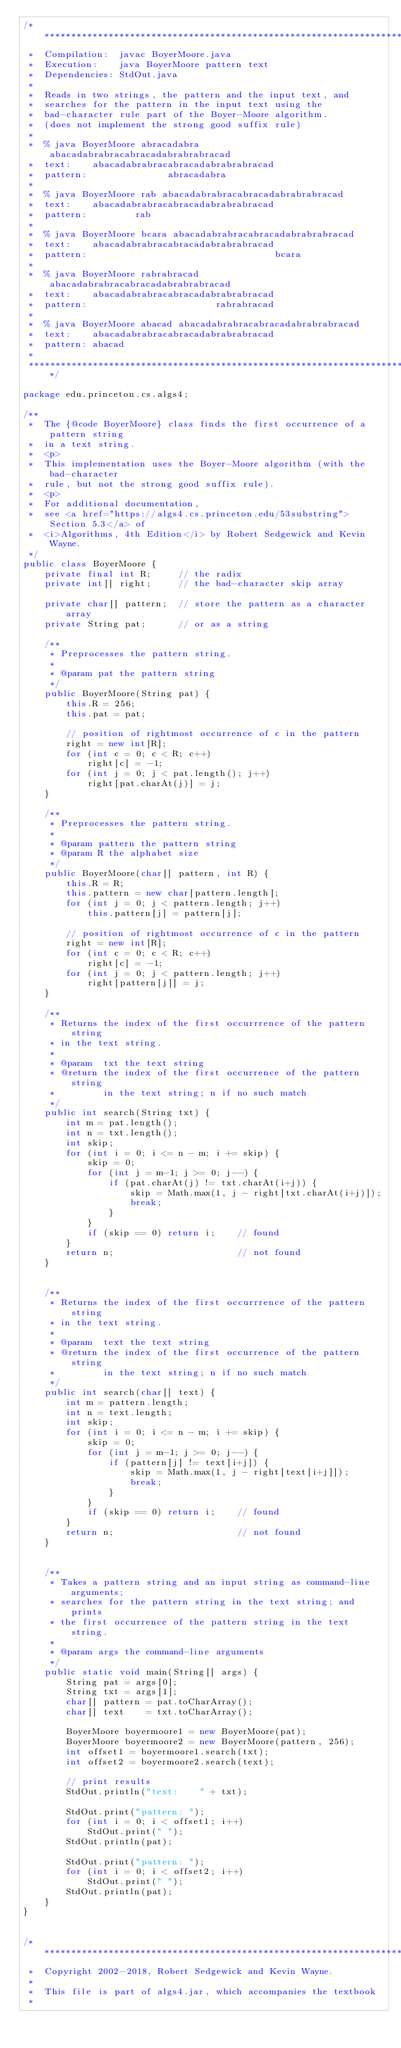<code> <loc_0><loc_0><loc_500><loc_500><_Java_>/******************************************************************************
 *  Compilation:  javac BoyerMoore.java
 *  Execution:    java BoyerMoore pattern text
 *  Dependencies: StdOut.java
 *
 *  Reads in two strings, the pattern and the input text, and
 *  searches for the pattern in the input text using the
 *  bad-character rule part of the Boyer-Moore algorithm.
 *  (does not implement the strong good suffix rule)
 *
 *  % java BoyerMoore abracadabra abacadabrabracabracadabrabrabracad
 *  text:    abacadabrabracabracadabrabrabracad 
 *  pattern:               abracadabra
 *
 *  % java BoyerMoore rab abacadabrabracabracadabrabrabracad
 *  text:    abacadabrabracabracadabrabrabracad 
 *  pattern:         rab
 *
 *  % java BoyerMoore bcara abacadabrabracabracadabrabrabracad
 *  text:    abacadabrabracabracadabrabrabracad 
 *  pattern:                                   bcara
 *
 *  % java BoyerMoore rabrabracad abacadabrabracabracadabrabrabracad
 *  text:    abacadabrabracabracadabrabrabracad
 *  pattern:                        rabrabracad
 *
 *  % java BoyerMoore abacad abacadabrabracabracadabrabrabracad
 *  text:    abacadabrabracabracadabrabrabracad
 *  pattern: abacad
 *
 ******************************************************************************/

package edu.princeton.cs.algs4;

/**
 *  The {@code BoyerMoore} class finds the first occurrence of a pattern string
 *  in a text string.
 *  <p>
 *  This implementation uses the Boyer-Moore algorithm (with the bad-character
 *  rule, but not the strong good suffix rule).
 *  <p>
 *  For additional documentation,
 *  see <a href="https://algs4.cs.princeton.edu/53substring">Section 5.3</a> of
 *  <i>Algorithms, 4th Edition</i> by Robert Sedgewick and Kevin Wayne.
 */
public class BoyerMoore {
    private final int R;     // the radix
    private int[] right;     // the bad-character skip array

    private char[] pattern;  // store the pattern as a character array
    private String pat;      // or as a string

    /**
     * Preprocesses the pattern string.
     *
     * @param pat the pattern string
     */
    public BoyerMoore(String pat) {
        this.R = 256;
        this.pat = pat;

        // position of rightmost occurrence of c in the pattern
        right = new int[R];
        for (int c = 0; c < R; c++)
            right[c] = -1;
        for (int j = 0; j < pat.length(); j++)
            right[pat.charAt(j)] = j;
    }

    /**
     * Preprocesses the pattern string.
     *
     * @param pattern the pattern string
     * @param R the alphabet size
     */
    public BoyerMoore(char[] pattern, int R) {
        this.R = R;
        this.pattern = new char[pattern.length];
        for (int j = 0; j < pattern.length; j++)
            this.pattern[j] = pattern[j];

        // position of rightmost occurrence of c in the pattern
        right = new int[R];
        for (int c = 0; c < R; c++)
            right[c] = -1;
        for (int j = 0; j < pattern.length; j++)
            right[pattern[j]] = j;
    }

    /**
     * Returns the index of the first occurrrence of the pattern string
     * in the text string.
     *
     * @param  txt the text string
     * @return the index of the first occurrence of the pattern string
     *         in the text string; n if no such match
     */
    public int search(String txt) {
        int m = pat.length();
        int n = txt.length();
        int skip;
        for (int i = 0; i <= n - m; i += skip) {
            skip = 0;
            for (int j = m-1; j >= 0; j--) {
                if (pat.charAt(j) != txt.charAt(i+j)) {
                    skip = Math.max(1, j - right[txt.charAt(i+j)]);
                    break;
                }
            }
            if (skip == 0) return i;    // found
        }
        return n;                       // not found
    }


    /**
     * Returns the index of the first occurrrence of the pattern string
     * in the text string.
     *
     * @param  text the text string
     * @return the index of the first occurrence of the pattern string
     *         in the text string; n if no such match
     */
    public int search(char[] text) {
        int m = pattern.length;
        int n = text.length;
        int skip;
        for (int i = 0; i <= n - m; i += skip) {
            skip = 0;
            for (int j = m-1; j >= 0; j--) {
                if (pattern[j] != text[i+j]) {
                    skip = Math.max(1, j - right[text[i+j]]);
                    break;
                }
            }
            if (skip == 0) return i;    // found
        }
        return n;                       // not found
    }


    /**
     * Takes a pattern string and an input string as command-line arguments;
     * searches for the pattern string in the text string; and prints
     * the first occurrence of the pattern string in the text string.
     *
     * @param args the command-line arguments
     */
    public static void main(String[] args) {
        String pat = args[0];
        String txt = args[1];
        char[] pattern = pat.toCharArray();
        char[] text    = txt.toCharArray();

        BoyerMoore boyermoore1 = new BoyerMoore(pat);
        BoyerMoore boyermoore2 = new BoyerMoore(pattern, 256);
        int offset1 = boyermoore1.search(txt);
        int offset2 = boyermoore2.search(text);

        // print results
        StdOut.println("text:    " + txt);

        StdOut.print("pattern: ");
        for (int i = 0; i < offset1; i++)
            StdOut.print(" ");
        StdOut.println(pat);

        StdOut.print("pattern: ");
        for (int i = 0; i < offset2; i++)
            StdOut.print(" ");
        StdOut.println(pat);
    }
}


/******************************************************************************
 *  Copyright 2002-2018, Robert Sedgewick and Kevin Wayne.
 *
 *  This file is part of algs4.jar, which accompanies the textbook
 *</code> 